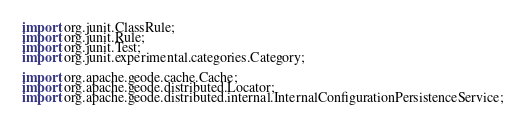<code> <loc_0><loc_0><loc_500><loc_500><_Java_>import org.junit.ClassRule;
import org.junit.Rule;
import org.junit.Test;
import org.junit.experimental.categories.Category;

import org.apache.geode.cache.Cache;
import org.apache.geode.distributed.Locator;
import org.apache.geode.distributed.internal.InternalConfigurationPersistenceService;</code> 